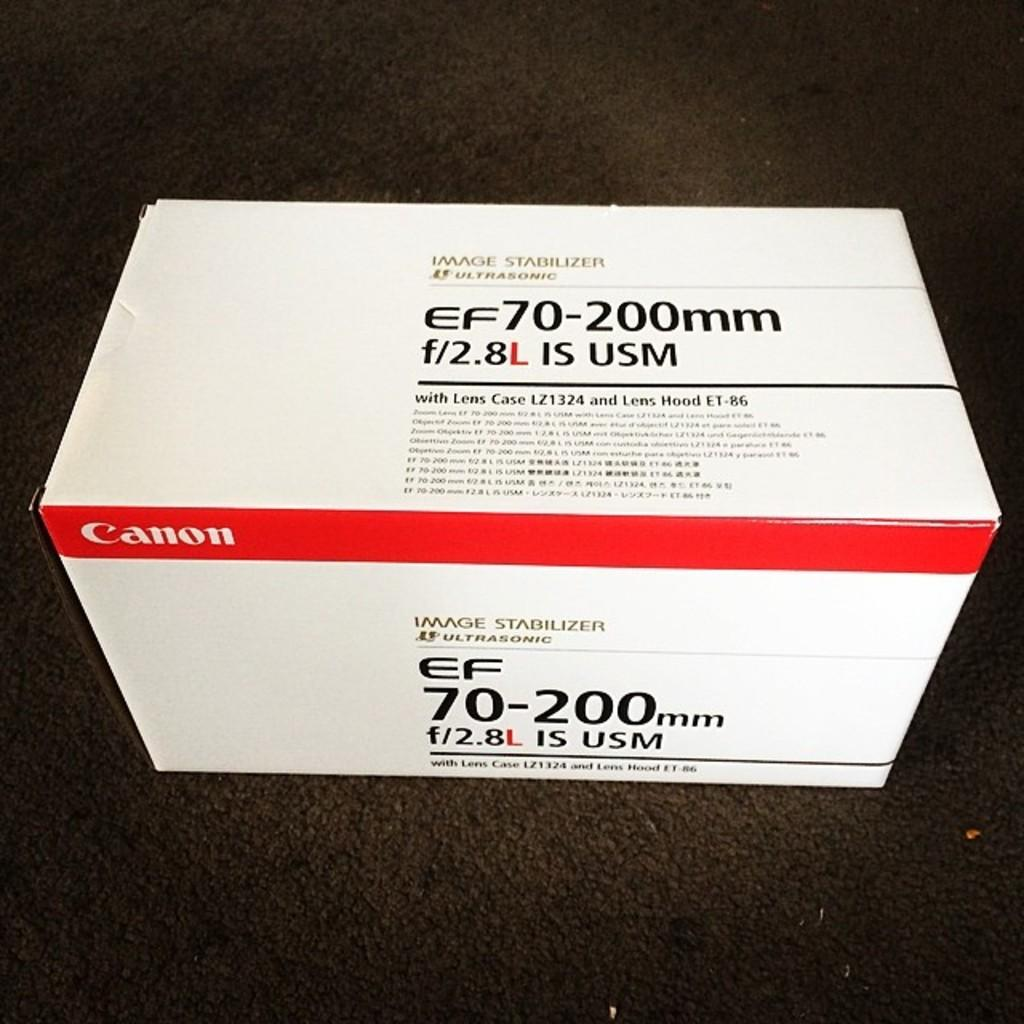<image>
Share a concise interpretation of the image provided. A box for a Canon EF70-200mm lens sits on the floor. 